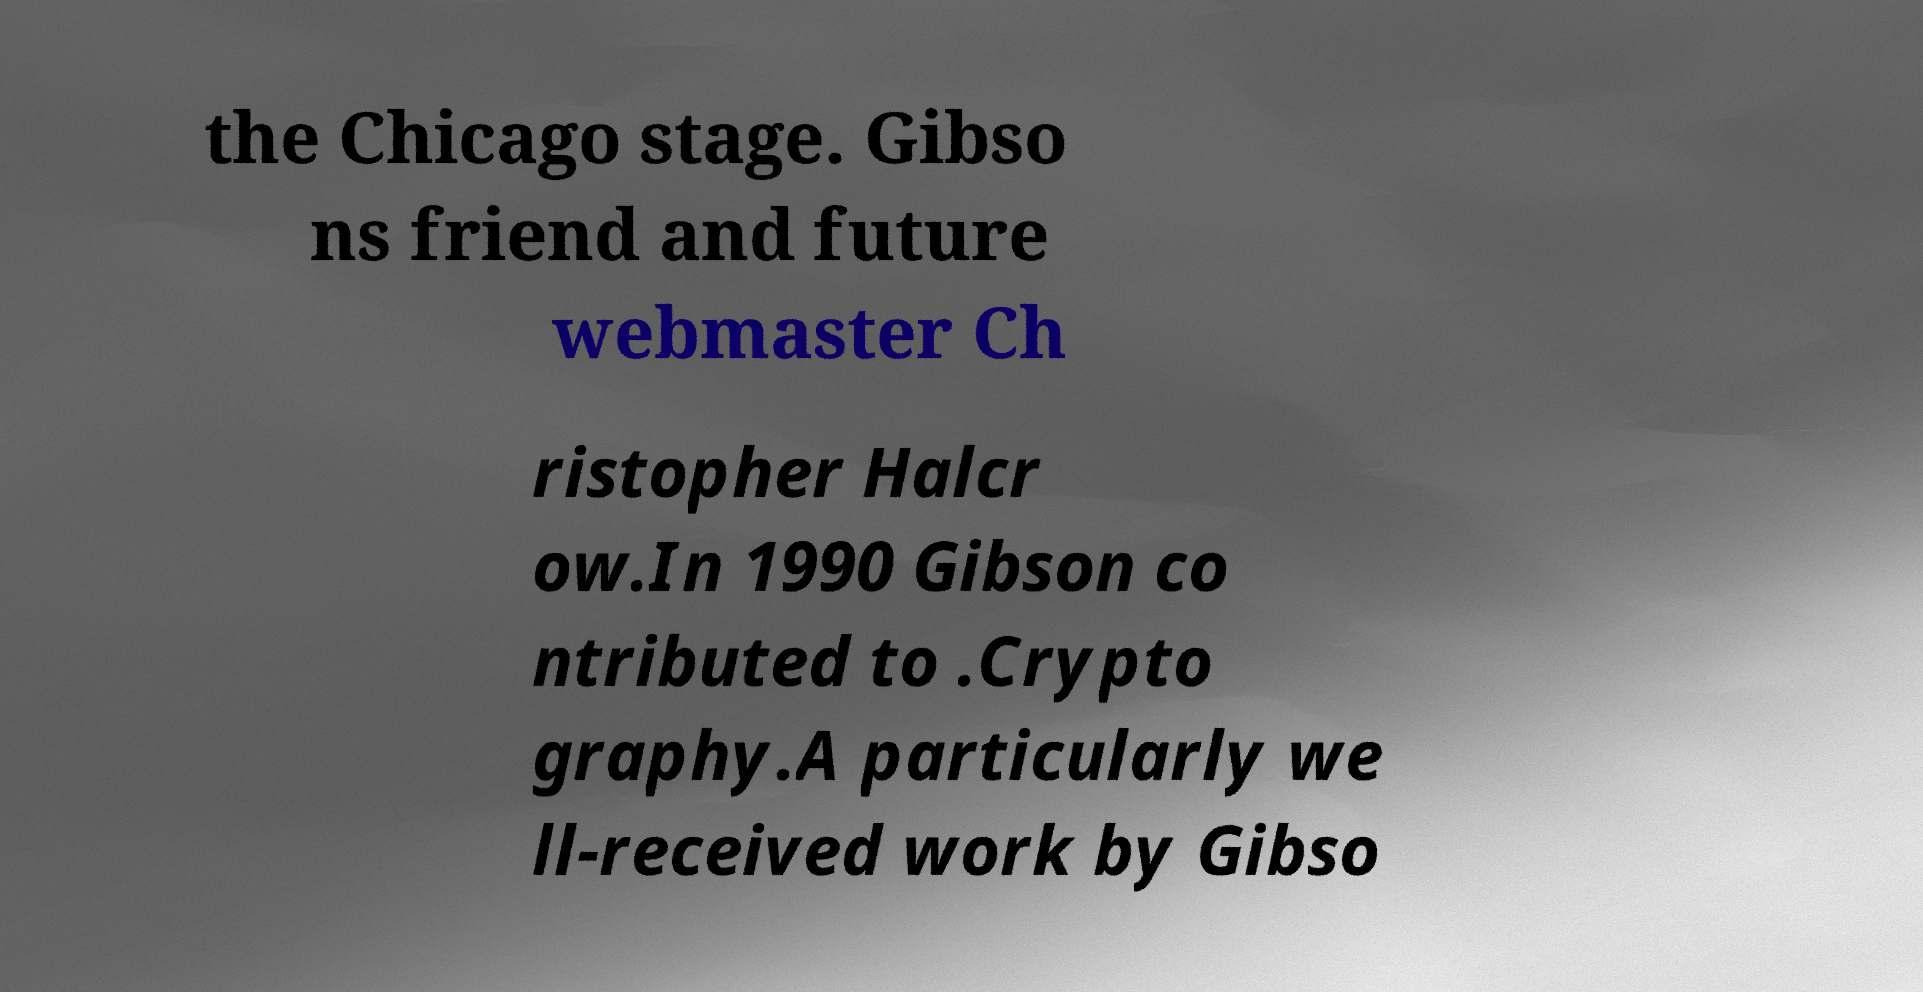Could you assist in decoding the text presented in this image and type it out clearly? the Chicago stage. Gibso ns friend and future webmaster Ch ristopher Halcr ow.In 1990 Gibson co ntributed to .Crypto graphy.A particularly we ll-received work by Gibso 